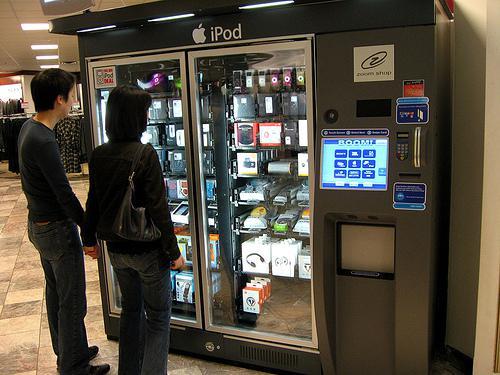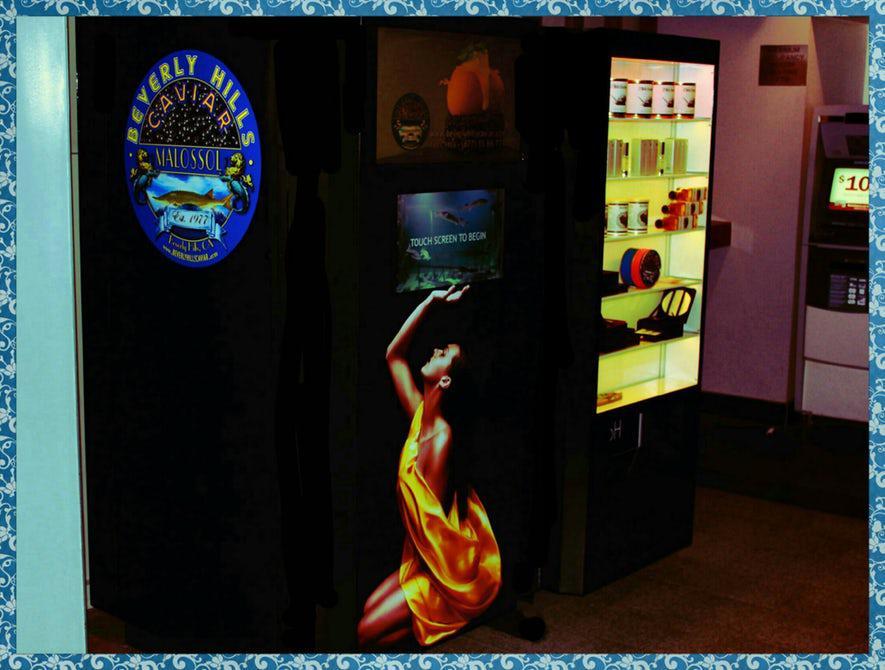The first image is the image on the left, the second image is the image on the right. Considering the images on both sides, is "At least one image shows at least one person standing in front of a vending machine." valid? Answer yes or no. Yes. The first image is the image on the left, the second image is the image on the right. Analyze the images presented: Is the assertion "One of the images has a male looking directly at the machine." valid? Answer yes or no. Yes. 